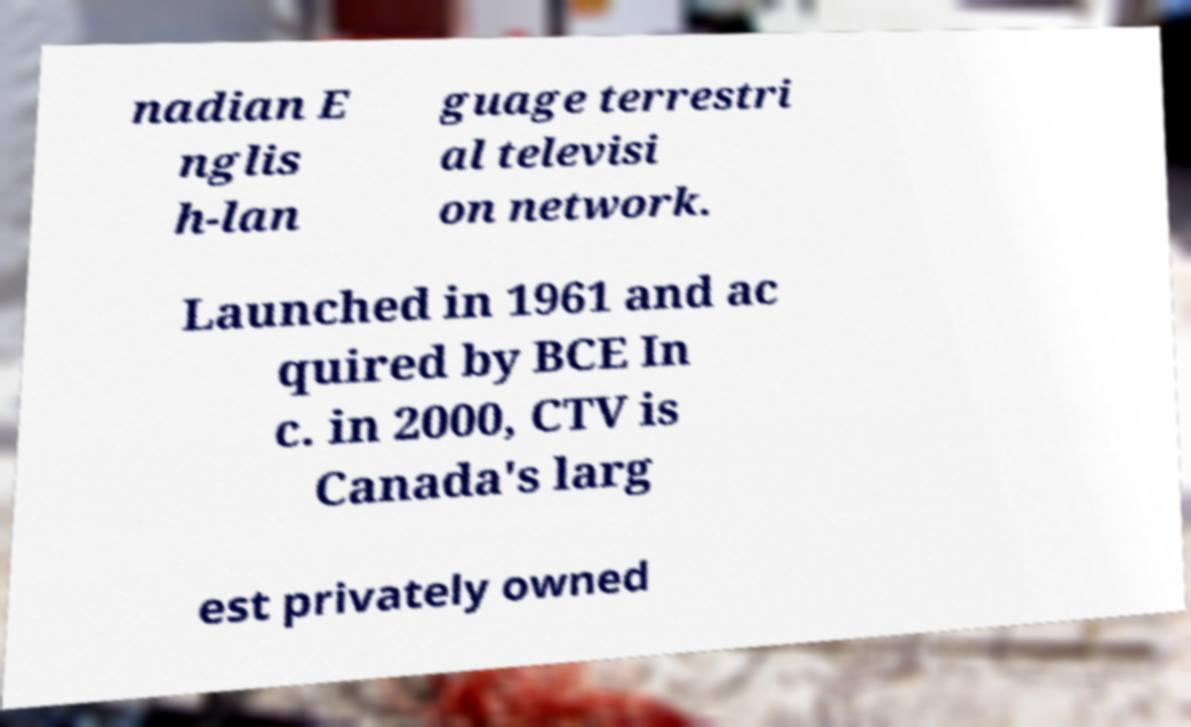What messages or text are displayed in this image? I need them in a readable, typed format. nadian E nglis h-lan guage terrestri al televisi on network. Launched in 1961 and ac quired by BCE In c. in 2000, CTV is Canada's larg est privately owned 